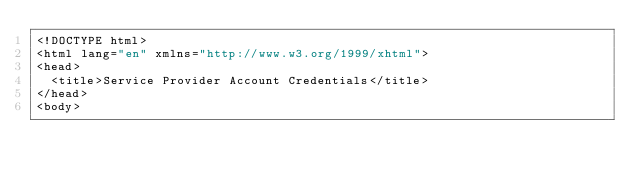<code> <loc_0><loc_0><loc_500><loc_500><_PHP_><!DOCTYPE html>
<html lang="en" xmlns="http://www.w3.org/1999/xhtml">
<head>
	<title>Service Provider Account Credentials</title>
</head>
<body>
</code> 